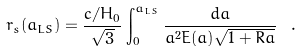Convert formula to latex. <formula><loc_0><loc_0><loc_500><loc_500>r _ { s } ( a _ { L S } ) = \frac { c / H _ { 0 } } { \sqrt { 3 } } \int _ { 0 } ^ { a _ { L S } } { \frac { d a } { a ^ { 2 } E ( a ) \sqrt { 1 + R a } } } \ .</formula> 